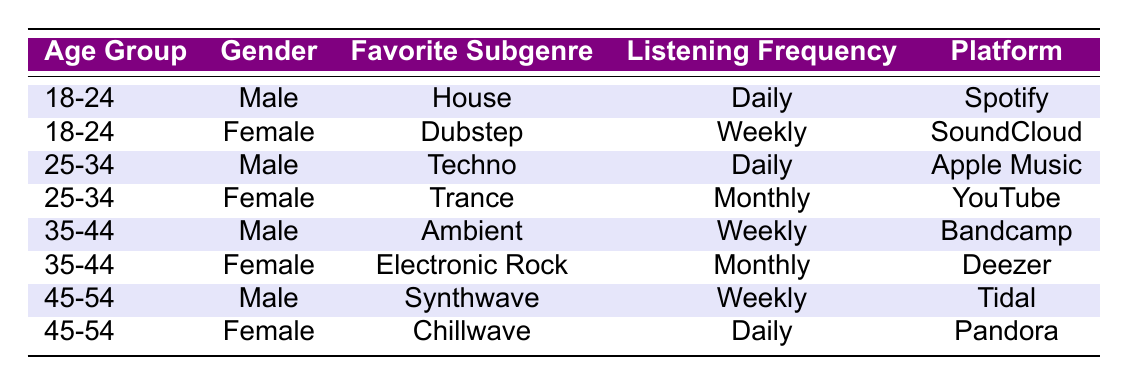What is the favorite subgenre of the 18-24-year-old female listeners? The table shows a row for the 18-24 age group of female listeners. Under the 'Favorite Subgenre' column, the value is 'Dubstep'.
Answer: Dubstep How many male listeners prefer a daily listening frequency? There are two rows where the listening frequency is 'Daily' for male listeners: one in the 18-24 age group (House) and one in the 25-34 age group (Techno). So, the count is 2.
Answer: 2 Which platform do 35-44-year-old female listeners use for music? The table shows a row for the 35-44 age group of female listeners, and the corresponding platform is 'Deezer'.
Answer: Deezer Is there a preferred subgenre for 45-54-year-old female listeners that has a daily listening frequency? Looking at the 45-54 age group, the female listener prefers 'Chillwave' and the listening frequency is 'Daily'. Thus, the statement is true.
Answer: Yes What is the average age group among all listeners in the table? The age groups represented are 18-24, 25-34, 35-44, and 45-54. To find the average, we assume a midpoint for each age group: 21, 29.5, 39.5, and 49.5, respectively. Adding these and dividing by 4 gives us (21 + 29.5 + 39.5 + 49.5) / 4 = 39.25. Hence, the average is 39.25.
Answer: 39.25 